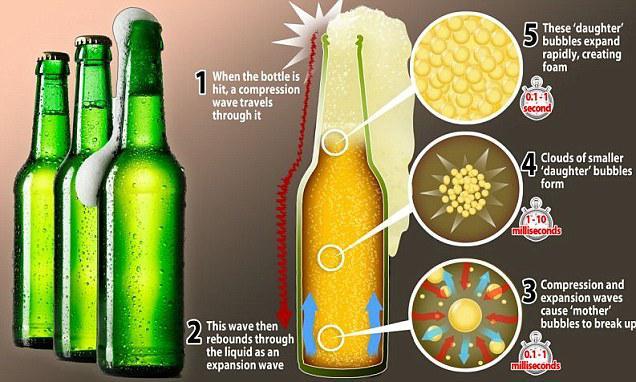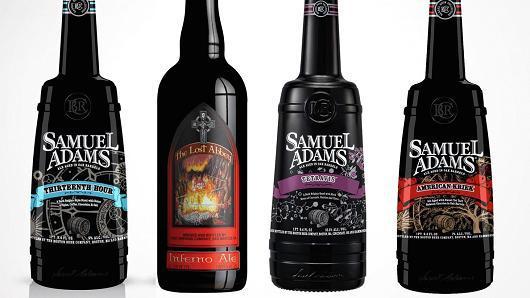The first image is the image on the left, the second image is the image on the right. Assess this claim about the two images: "The bottles in the image on the left don't have lablels.". Correct or not? Answer yes or no. Yes. The first image is the image on the left, the second image is the image on the right. For the images shown, is this caption "There is no more than 8 bottles." true? Answer yes or no. Yes. 